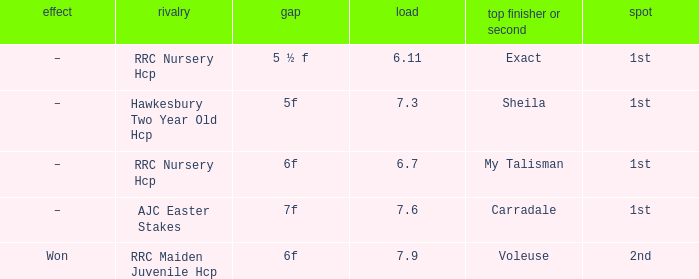What was the name of the winner or 2nd when the result was –, and weight was 6.7? My Talisman. 